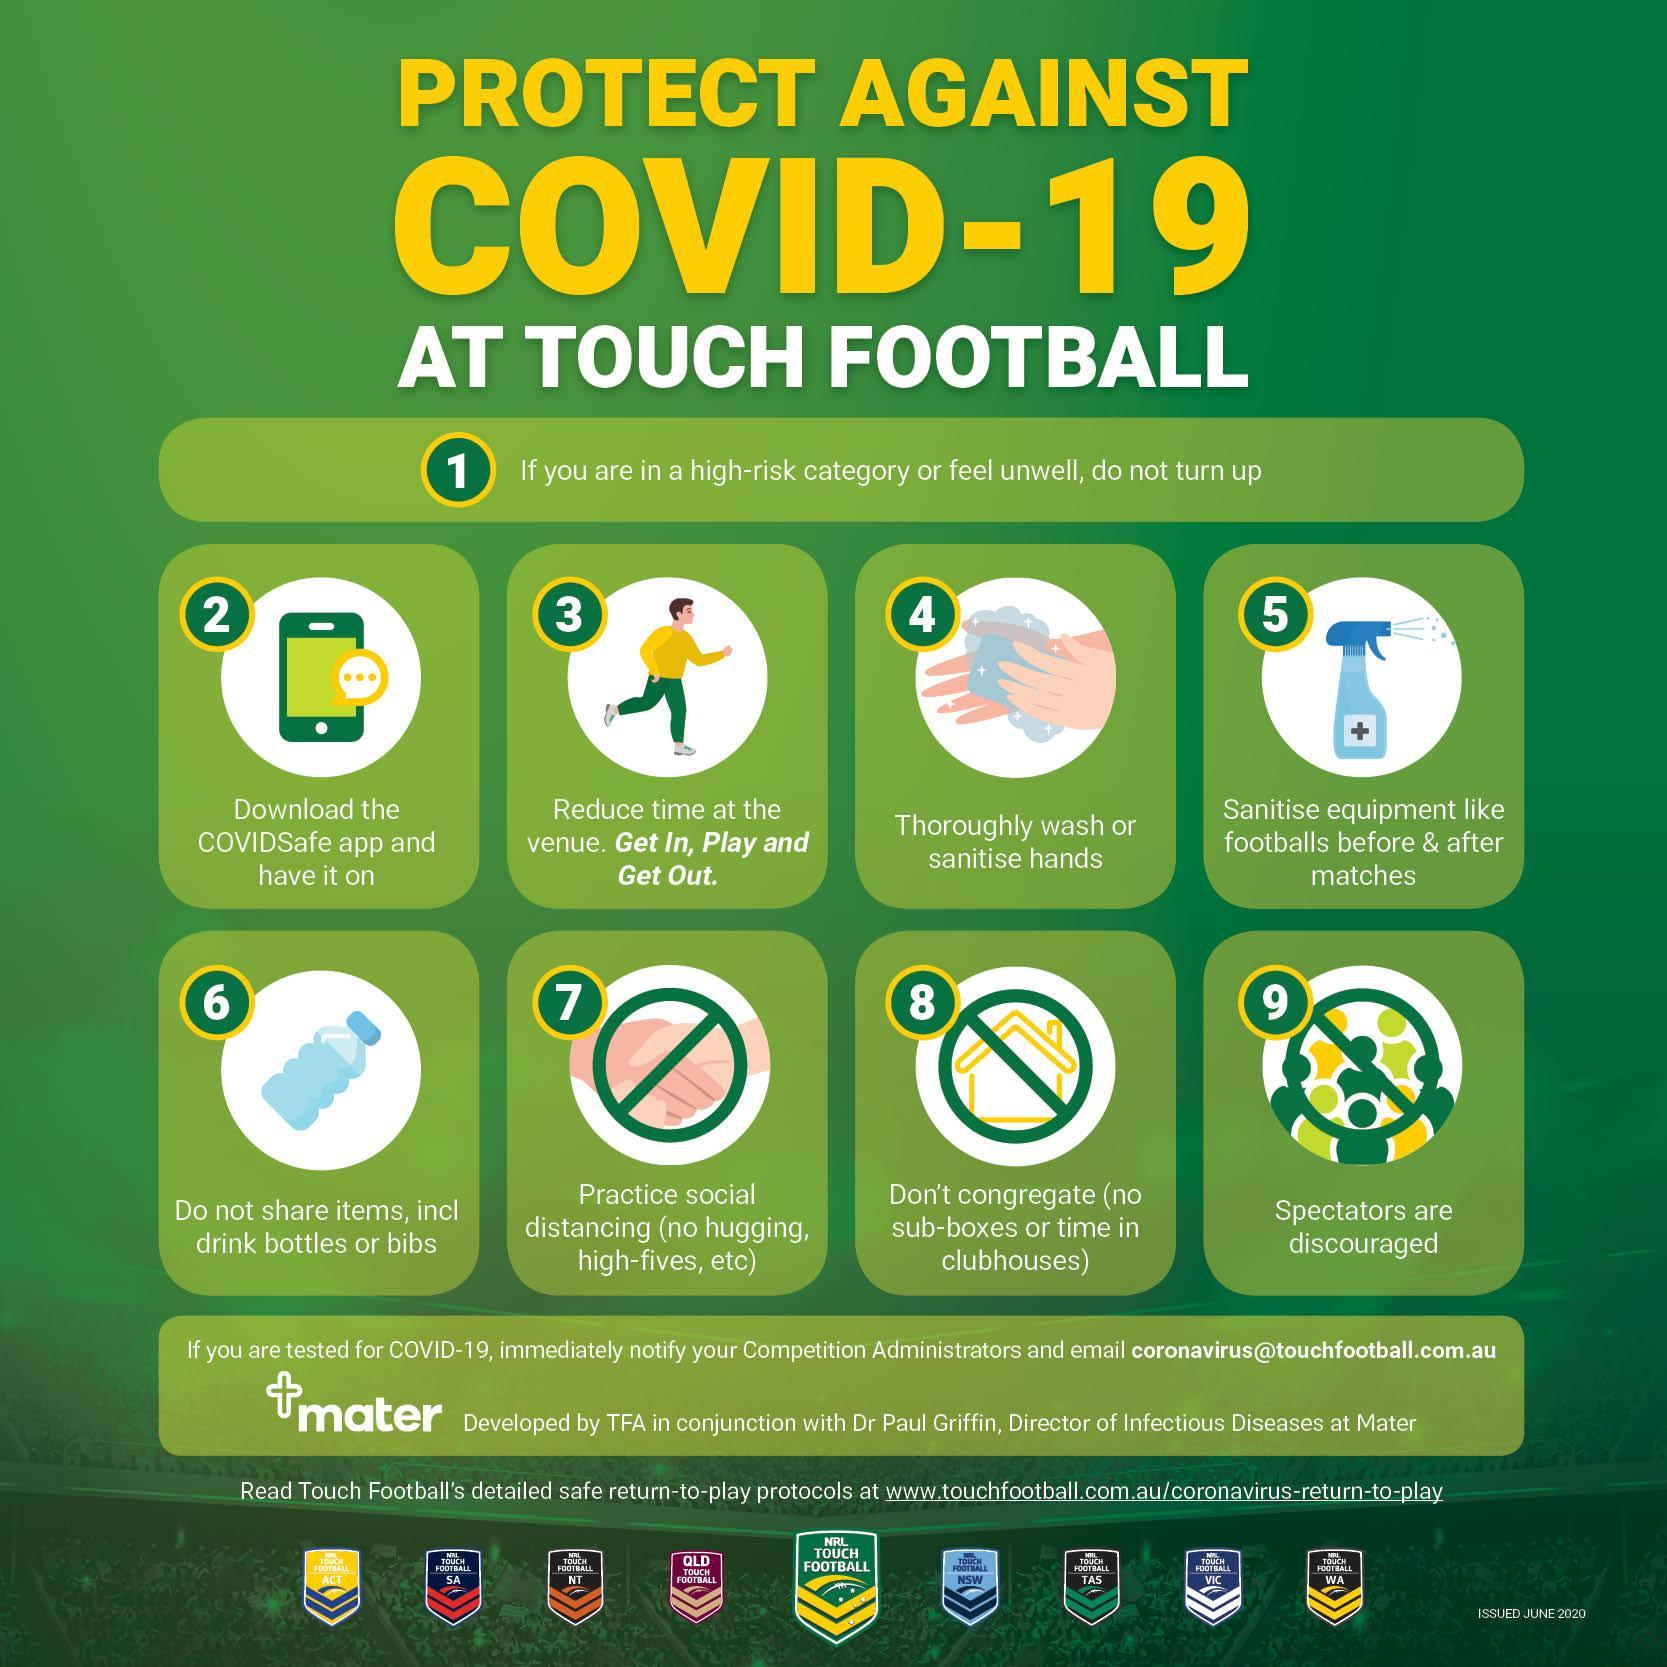How many don'ts are shown in this infographic image?
Answer the question with a short phrase. 3 